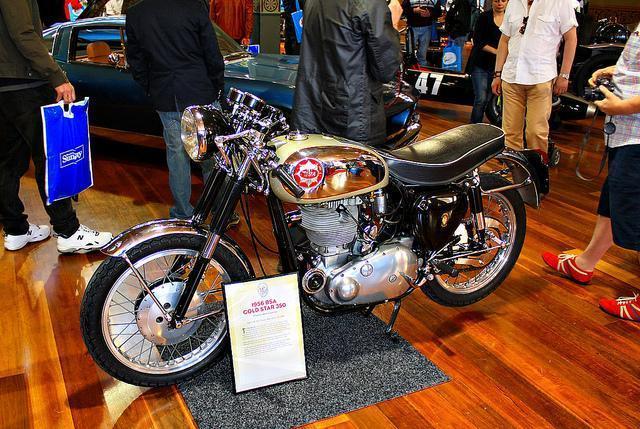How many cars can be seen?
Give a very brief answer. 1. How many people can be seen?
Give a very brief answer. 6. 